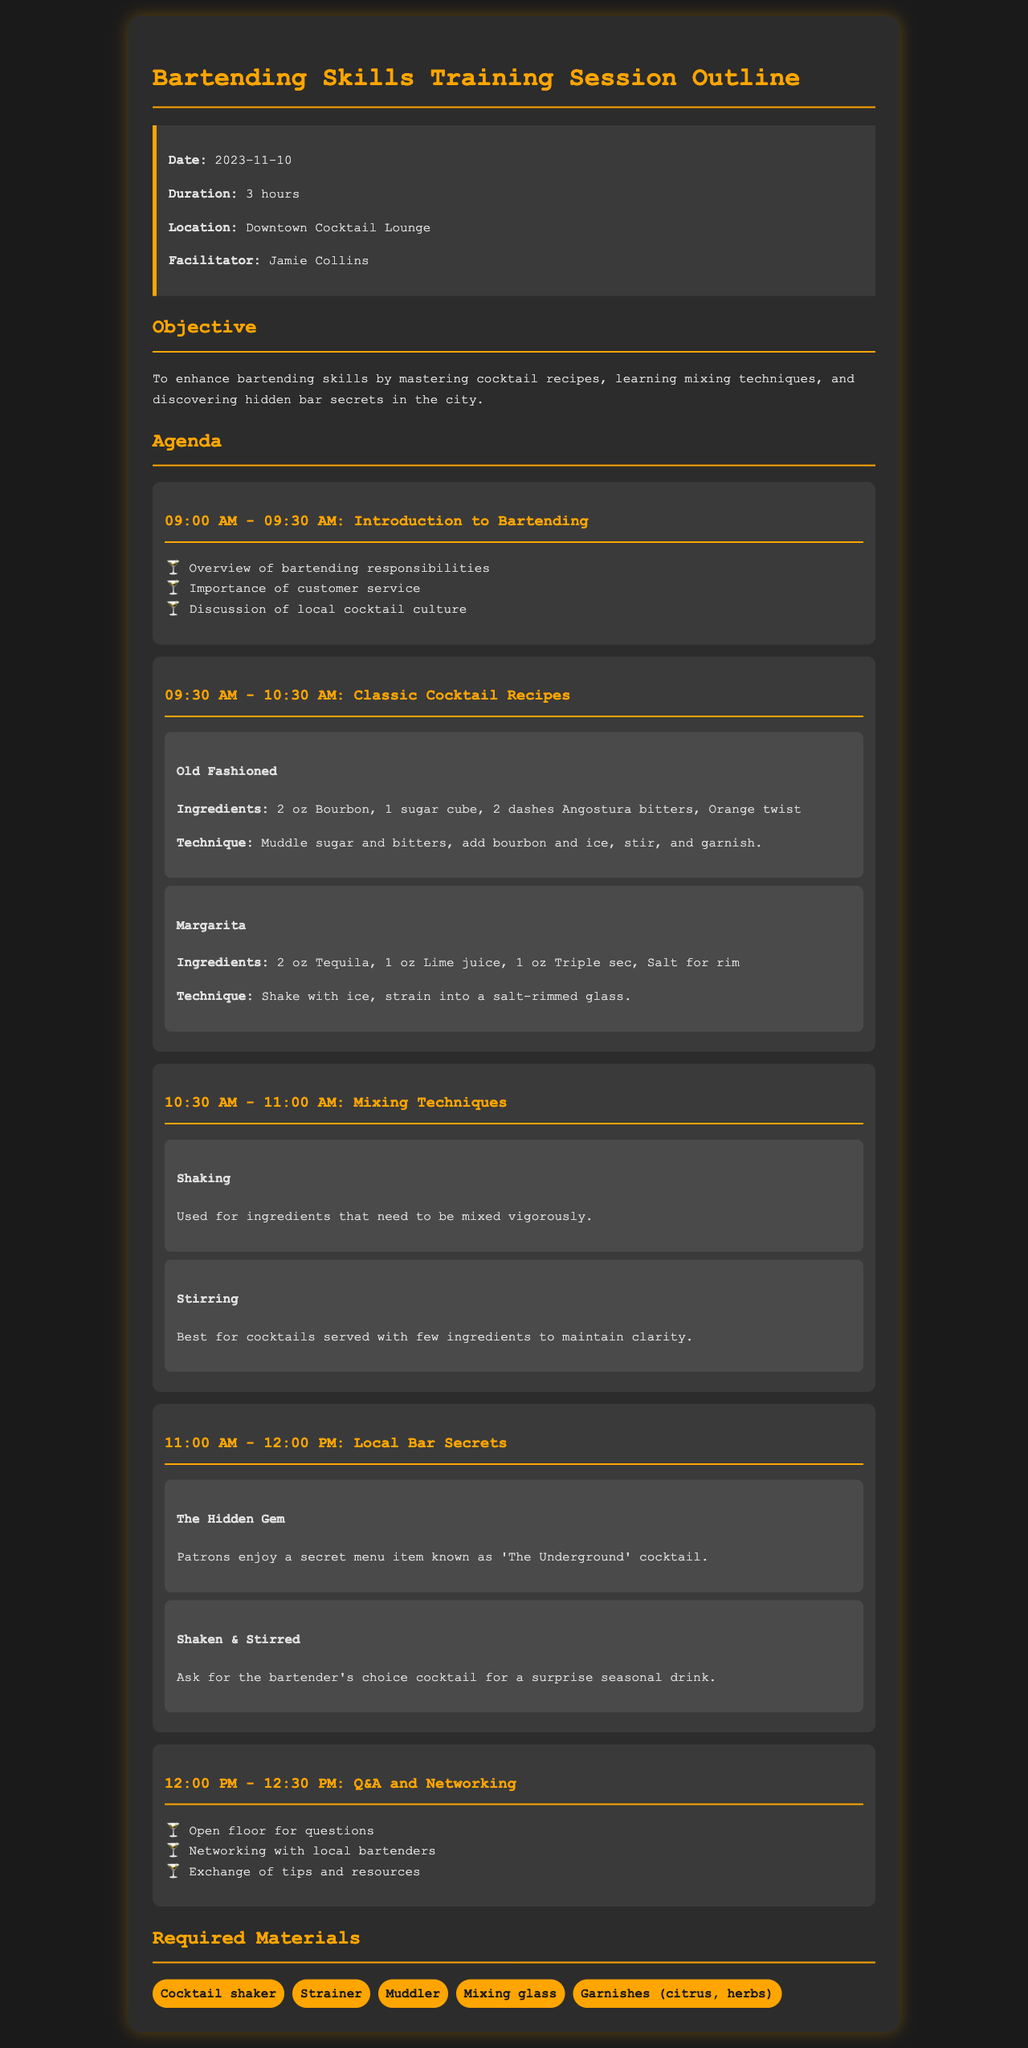What is the date of the training session? The date of the training session is clearly mentioned in the session details.
Answer: 2023-11-10 Who is the facilitator of the training session? The facilitator's name is provided in the session details section.
Answer: Jamie Collins How long is the training session scheduled for? The duration of the session is indicated in the session details.
Answer: 3 hours What cocktail is made with 2 oz of Tequila? The specific recipe for the cocktail can be found in the classic cocktail recipes section.
Answer: Margarita What is one technique mentioned for mixing cocktails? The document lists different techniques used in bartending, including mixing methods.
Answer: Shaking Which hidden cocktail is known as 'The Underground'? This secret cocktail is referenced in the local bar secrets section.
Answer: The Hidden Gem What time does the introduction to bartending start? The agenda provides specific times for each section of the session.
Answer: 09:00 AM What type of material is required for mixing cocktails? The required materials section lists several items needed for bartending.
Answer: Cocktail shaker What is the first item on the agenda? The agenda outlines the topics scheduled to be covered, starting with the first one listed.
Answer: Introduction to Bartending 